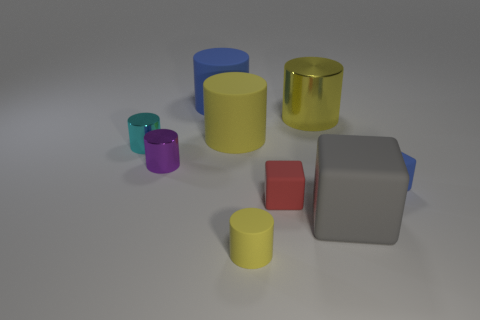There is a big thing that is in front of the large metal object and left of the small yellow rubber cylinder; what material is it made of?
Make the answer very short. Rubber. There is a cylinder left of the purple thing; is its size the same as the small red matte thing?
Give a very brief answer. Yes. Are there any other things that are the same size as the red object?
Give a very brief answer. Yes. Are there more small blue rubber things that are on the left side of the tiny purple object than big yellow objects behind the yellow shiny object?
Make the answer very short. No. There is a cylinder that is in front of the blue rubber thing that is to the right of the matte cylinder in front of the purple metallic object; what is its color?
Provide a short and direct response. Yellow. There is a metallic object that is on the left side of the small purple shiny cylinder; is its color the same as the large metallic cylinder?
Your answer should be very brief. No. What number of other things are there of the same color as the big rubber block?
Your answer should be very brief. 0. How many objects are purple cylinders or big rubber cubes?
Provide a short and direct response. 2. What number of things are either large gray matte things or metallic cylinders that are left of the big yellow matte cylinder?
Offer a terse response. 3. Does the large gray object have the same material as the red object?
Give a very brief answer. Yes. 